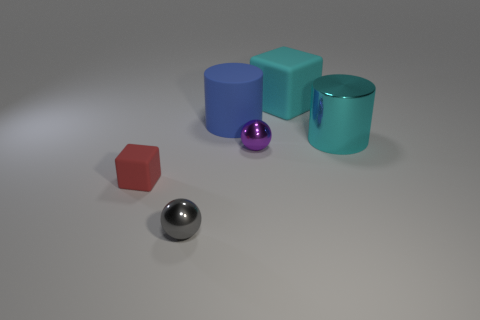Add 1 tiny brown spheres. How many objects exist? 7 Subtract all blocks. How many objects are left? 4 Add 1 big brown cylinders. How many big brown cylinders exist? 1 Subtract 1 gray balls. How many objects are left? 5 Subtract all blue metal blocks. Subtract all tiny gray metal spheres. How many objects are left? 5 Add 3 big metallic cylinders. How many big metallic cylinders are left? 4 